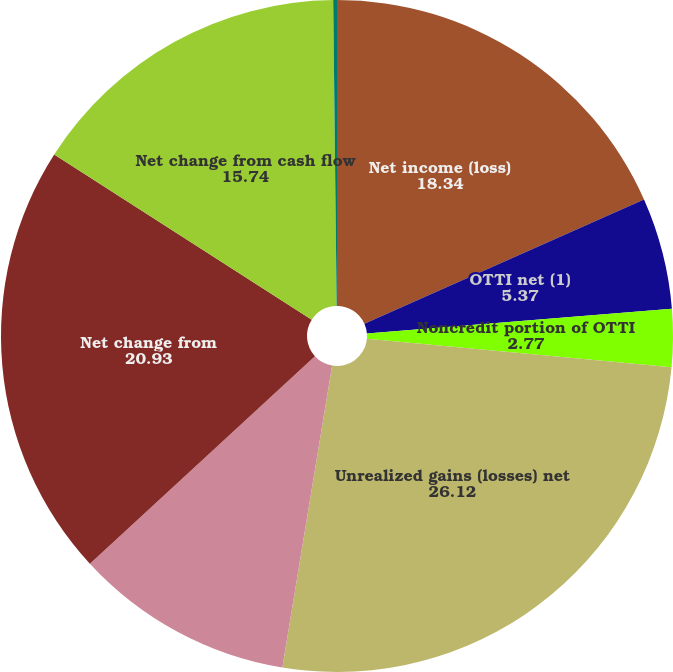Convert chart to OTSL. <chart><loc_0><loc_0><loc_500><loc_500><pie_chart><fcel>Net income (loss)<fcel>OTTI net (1)<fcel>Noncredit portion of OTTI<fcel>Unrealized gains (losses) net<fcel>Reclassification into earnings<fcel>Net change from<fcel>Net change from cash flow<fcel>Foreign currency translation<nl><fcel>18.34%<fcel>5.37%<fcel>2.77%<fcel>26.12%<fcel>10.55%<fcel>20.93%<fcel>15.74%<fcel>0.18%<nl></chart> 